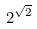Convert formula to latex. <formula><loc_0><loc_0><loc_500><loc_500>2 ^ { \sqrt { 2 } }</formula> 